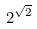Convert formula to latex. <formula><loc_0><loc_0><loc_500><loc_500>2 ^ { \sqrt { 2 } }</formula> 